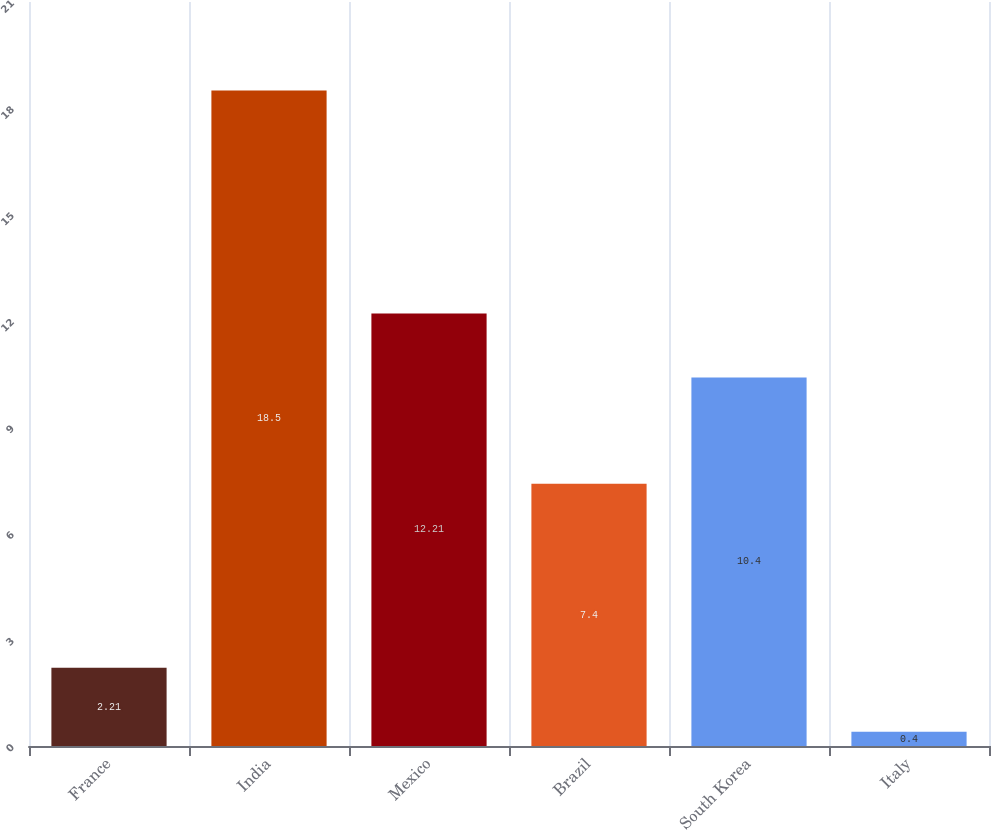Convert chart. <chart><loc_0><loc_0><loc_500><loc_500><bar_chart><fcel>France<fcel>India<fcel>Mexico<fcel>Brazil<fcel>South Korea<fcel>Italy<nl><fcel>2.21<fcel>18.5<fcel>12.21<fcel>7.4<fcel>10.4<fcel>0.4<nl></chart> 